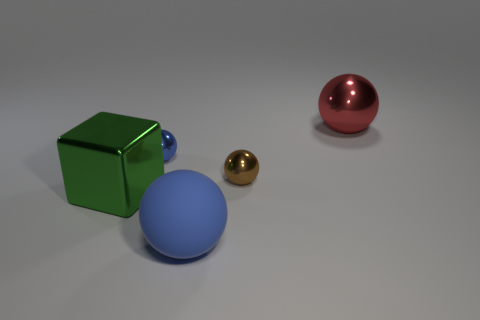Add 1 purple matte things. How many objects exist? 6 Subtract all tiny brown metallic spheres. Subtract all blue metal things. How many objects are left? 3 Add 1 red balls. How many red balls are left? 2 Add 1 yellow metal things. How many yellow metal things exist? 1 Subtract all brown spheres. How many spheres are left? 3 Subtract all matte spheres. How many spheres are left? 3 Subtract 2 blue balls. How many objects are left? 3 Subtract all blocks. How many objects are left? 4 Subtract 2 spheres. How many spheres are left? 2 Subtract all gray blocks. Subtract all red cylinders. How many blocks are left? 1 